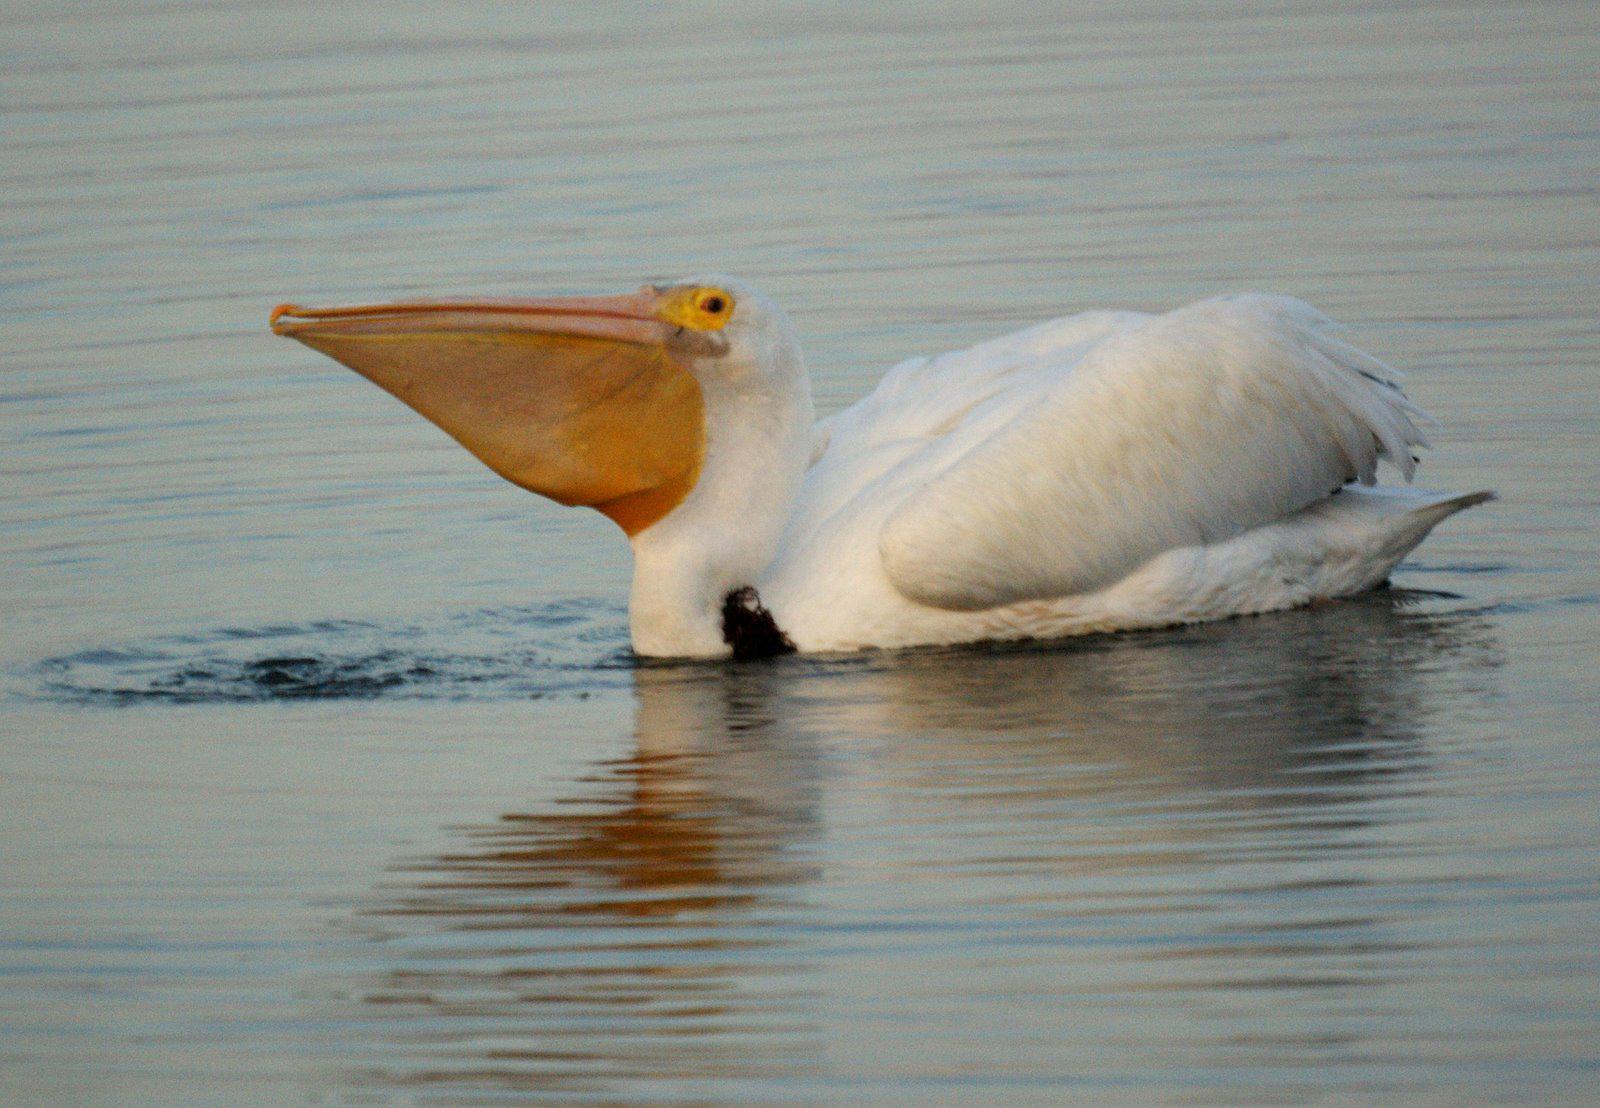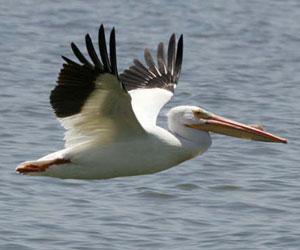The first image is the image on the left, the second image is the image on the right. Examine the images to the left and right. Is the description "The left image shows two pelicans on the water." accurate? Answer yes or no. No. 